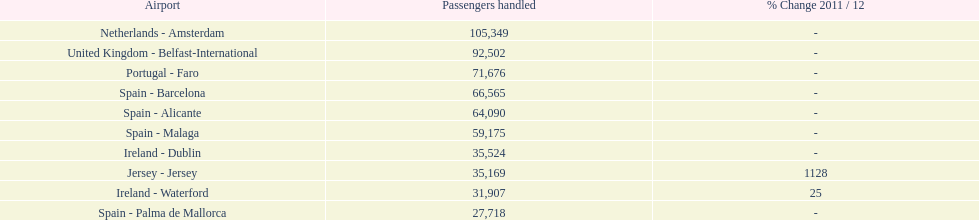Looking at the top 10 busiest routes to and from london southend airport what is the average number of passengers handled? 58,967.5. Could you parse the entire table as a dict? {'header': ['Airport', 'Passengers handled', '% Change 2011 / 12'], 'rows': [['Netherlands - Amsterdam', '105,349', '-'], ['United Kingdom - Belfast-International', '92,502', '-'], ['Portugal - Faro', '71,676', '-'], ['Spain - Barcelona', '66,565', '-'], ['Spain - Alicante', '64,090', '-'], ['Spain - Malaga', '59,175', '-'], ['Ireland - Dublin', '35,524', '-'], ['Jersey - Jersey', '35,169', '1128'], ['Ireland - Waterford', '31,907', '25'], ['Spain - Palma de Mallorca', '27,718', '-']]} 